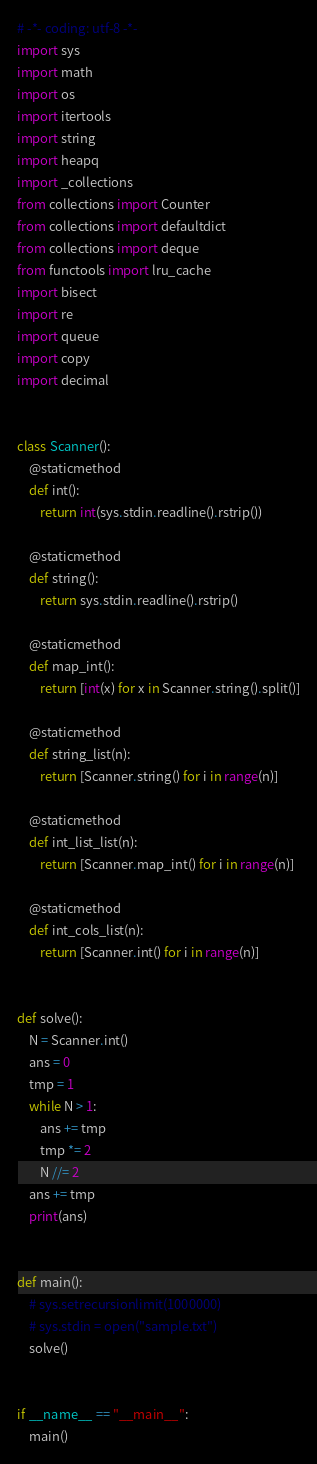Convert code to text. <code><loc_0><loc_0><loc_500><loc_500><_Python_># -*- coding: utf-8 -*-
import sys
import math
import os
import itertools
import string
import heapq
import _collections
from collections import Counter
from collections import defaultdict
from collections import deque
from functools import lru_cache
import bisect
import re
import queue
import copy
import decimal


class Scanner():
    @staticmethod
    def int():
        return int(sys.stdin.readline().rstrip())

    @staticmethod
    def string():
        return sys.stdin.readline().rstrip()

    @staticmethod
    def map_int():
        return [int(x) for x in Scanner.string().split()]

    @staticmethod
    def string_list(n):
        return [Scanner.string() for i in range(n)]

    @staticmethod
    def int_list_list(n):
        return [Scanner.map_int() for i in range(n)]

    @staticmethod
    def int_cols_list(n):
        return [Scanner.int() for i in range(n)]


def solve():
    N = Scanner.int()
    ans = 0
    tmp = 1
    while N > 1:
        ans += tmp
        tmp *= 2
        N //= 2
    ans += tmp
    print(ans)


def main():
    # sys.setrecursionlimit(1000000)
    # sys.stdin = open("sample.txt")
    solve()


if __name__ == "__main__":
    main()
</code> 